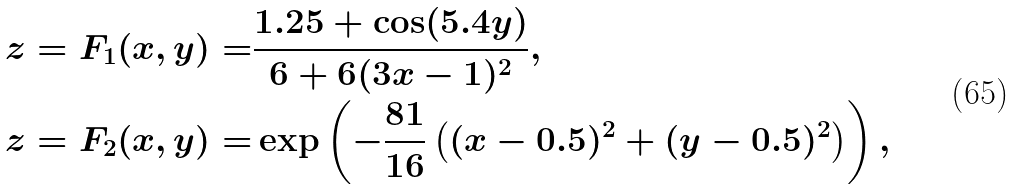Convert formula to latex. <formula><loc_0><loc_0><loc_500><loc_500>z = F _ { 1 } ( x , y ) = & \frac { 1 . 2 5 + \cos ( 5 . 4 y ) } { 6 + 6 ( 3 x - 1 ) ^ { 2 } } , \\ z = F _ { 2 } ( x , y ) = & \exp \left ( - \frac { 8 1 } { 1 6 } \left ( ( x - 0 . 5 ) ^ { 2 } + ( y - 0 . 5 ) ^ { 2 } \right ) \right ) ,</formula> 